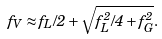Convert formula to latex. <formula><loc_0><loc_0><loc_500><loc_500>f _ { V } \approx f _ { L } / 2 + { \sqrt { f _ { L } ^ { 2 } / 4 + f _ { G } ^ { 2 } } } .</formula> 